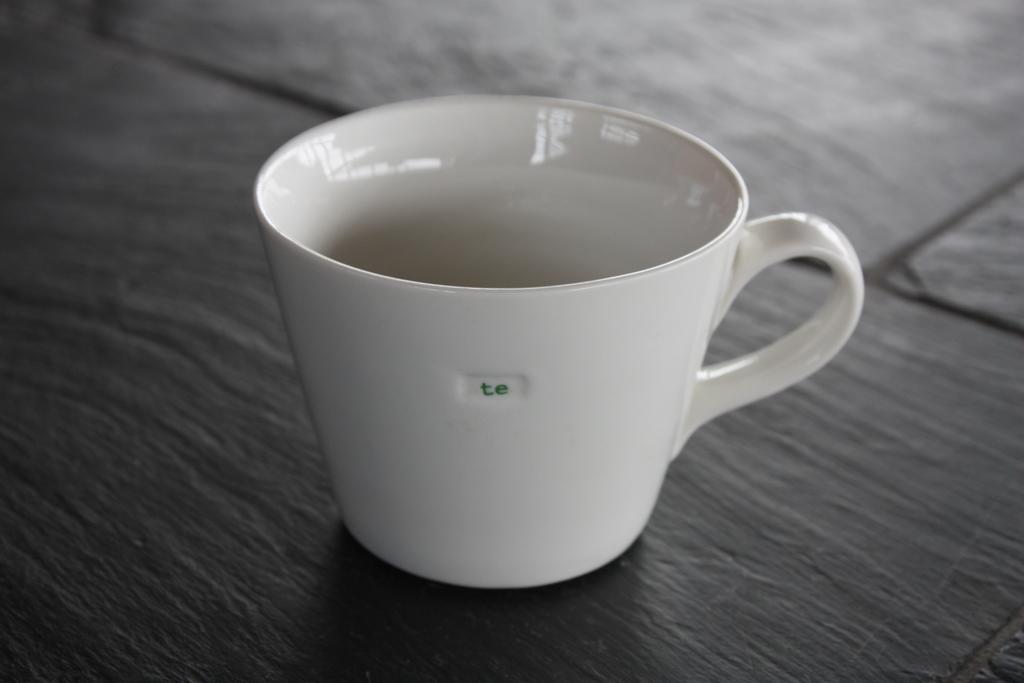Please provide a concise description of this image. We can observe a white color cup placed on the table. The table is in black color. 